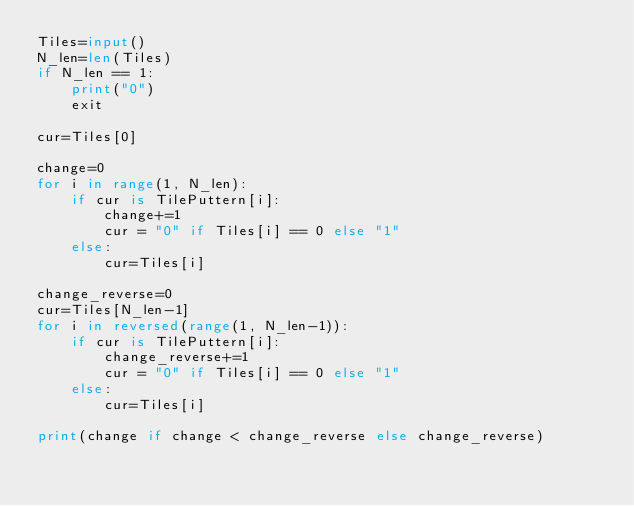<code> <loc_0><loc_0><loc_500><loc_500><_Python_>Tiles=input()
N_len=len(Tiles)
if N_len == 1:
    print("0")
    exit
    
cur=Tiles[0]

change=0
for i in range(1, N_len):
    if cur is TilePuttern[i]:
        change+=1
        cur = "0" if Tiles[i] == 0 else "1"
    else:
        cur=Tiles[i]
        
change_reverse=0
cur=Tiles[N_len-1]
for i in reversed(range(1, N_len-1)):
    if cur is TilePuttern[i]:
        change_reverse+=1
        cur = "0" if Tiles[i] == 0 else "1"
    else:
        cur=Tiles[i]

print(change if change < change_reverse else change_reverse)</code> 